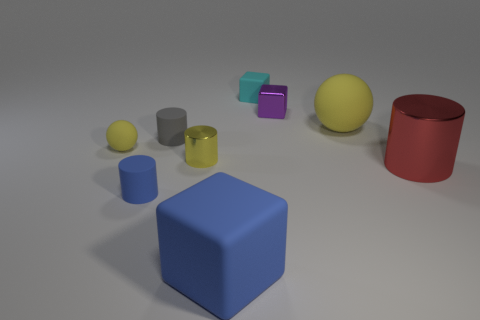Subtract all cylinders. How many objects are left? 5 Add 3 yellow rubber balls. How many yellow rubber balls are left? 5 Add 9 metal cubes. How many metal cubes exist? 10 Subtract 0 green cylinders. How many objects are left? 9 Subtract all small cyan matte cylinders. Subtract all tiny gray cylinders. How many objects are left? 8 